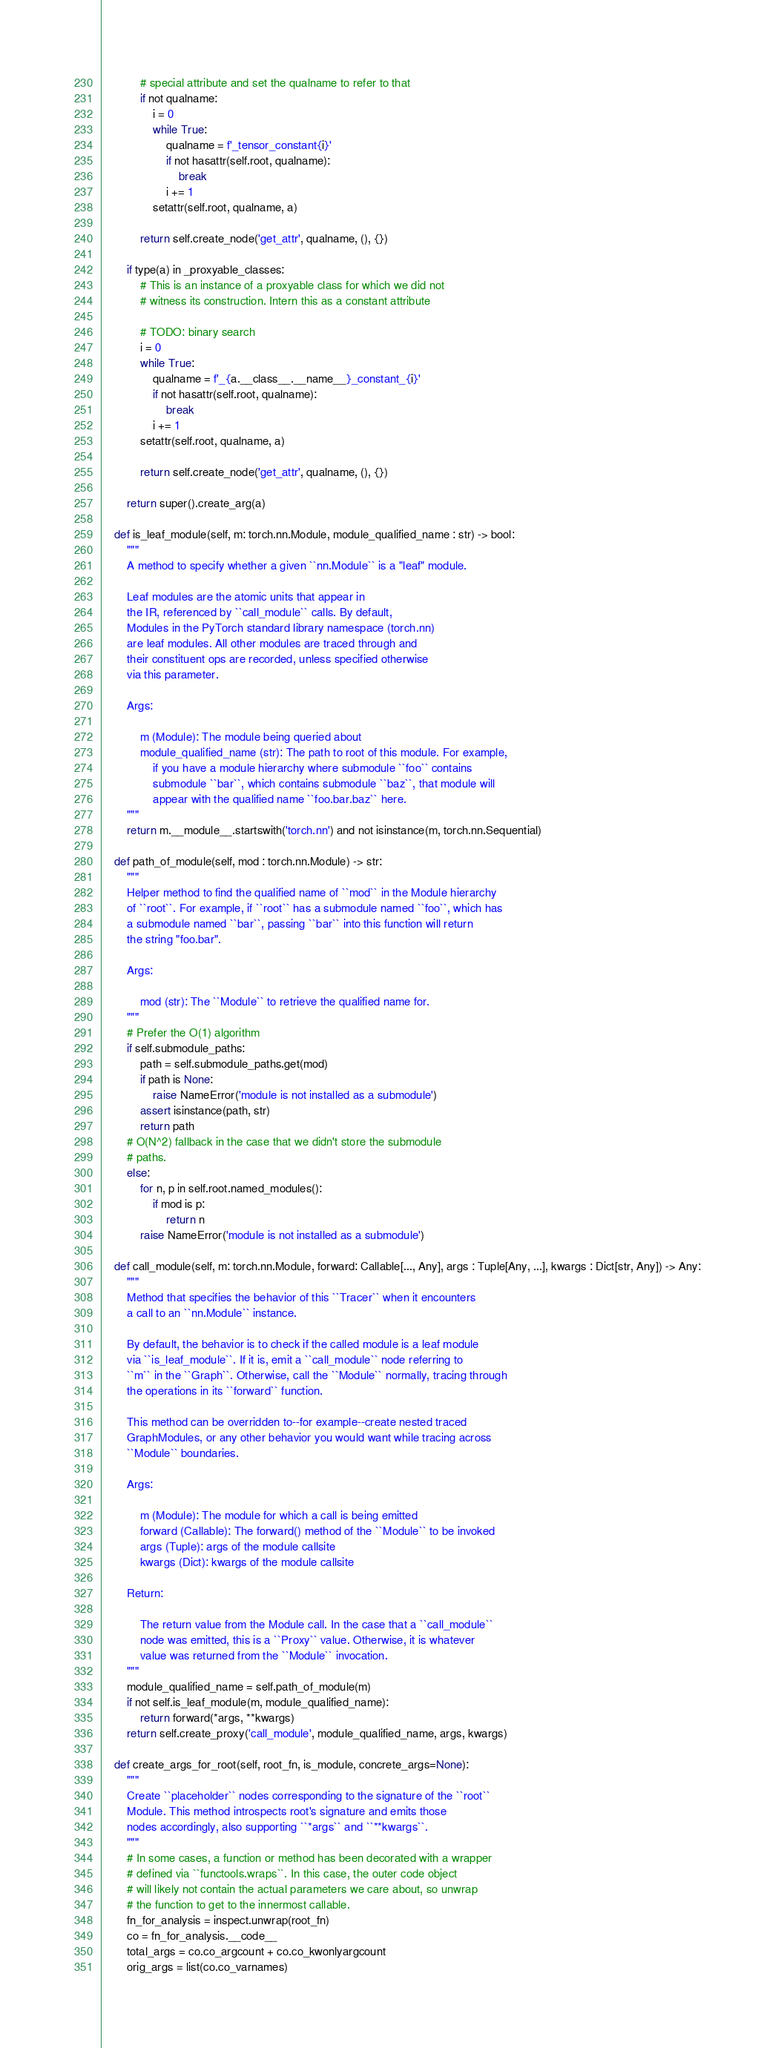Convert code to text. <code><loc_0><loc_0><loc_500><loc_500><_Python_>            # special attribute and set the qualname to refer to that
            if not qualname:
                i = 0
                while True:
                    qualname = f'_tensor_constant{i}'
                    if not hasattr(self.root, qualname):
                        break
                    i += 1
                setattr(self.root, qualname, a)

            return self.create_node('get_attr', qualname, (), {})

        if type(a) in _proxyable_classes:
            # This is an instance of a proxyable class for which we did not
            # witness its construction. Intern this as a constant attribute

            # TODO: binary search
            i = 0
            while True:
                qualname = f'_{a.__class__.__name__}_constant_{i}'
                if not hasattr(self.root, qualname):
                    break
                i += 1
            setattr(self.root, qualname, a)

            return self.create_node('get_attr', qualname, (), {})

        return super().create_arg(a)

    def is_leaf_module(self, m: torch.nn.Module, module_qualified_name : str) -> bool:
        """
        A method to specify whether a given ``nn.Module`` is a "leaf" module.

        Leaf modules are the atomic units that appear in
        the IR, referenced by ``call_module`` calls. By default,
        Modules in the PyTorch standard library namespace (torch.nn)
        are leaf modules. All other modules are traced through and
        their constituent ops are recorded, unless specified otherwise
        via this parameter.

        Args:

            m (Module): The module being queried about
            module_qualified_name (str): The path to root of this module. For example,
                if you have a module hierarchy where submodule ``foo`` contains
                submodule ``bar``, which contains submodule ``baz``, that module will
                appear with the qualified name ``foo.bar.baz`` here.
        """
        return m.__module__.startswith('torch.nn') and not isinstance(m, torch.nn.Sequential)

    def path_of_module(self, mod : torch.nn.Module) -> str:
        """
        Helper method to find the qualified name of ``mod`` in the Module hierarchy
        of ``root``. For example, if ``root`` has a submodule named ``foo``, which has
        a submodule named ``bar``, passing ``bar`` into this function will return
        the string "foo.bar".

        Args:

            mod (str): The ``Module`` to retrieve the qualified name for.
        """
        # Prefer the O(1) algorithm
        if self.submodule_paths:
            path = self.submodule_paths.get(mod)
            if path is None:
                raise NameError('module is not installed as a submodule')
            assert isinstance(path, str)
            return path
        # O(N^2) fallback in the case that we didn't store the submodule
        # paths.
        else:
            for n, p in self.root.named_modules():
                if mod is p:
                    return n
            raise NameError('module is not installed as a submodule')

    def call_module(self, m: torch.nn.Module, forward: Callable[..., Any], args : Tuple[Any, ...], kwargs : Dict[str, Any]) -> Any:
        """
        Method that specifies the behavior of this ``Tracer`` when it encounters
        a call to an ``nn.Module`` instance.

        By default, the behavior is to check if the called module is a leaf module
        via ``is_leaf_module``. If it is, emit a ``call_module`` node referring to
        ``m`` in the ``Graph``. Otherwise, call the ``Module`` normally, tracing through
        the operations in its ``forward`` function.

        This method can be overridden to--for example--create nested traced
        GraphModules, or any other behavior you would want while tracing across
        ``Module`` boundaries.

        Args:

            m (Module): The module for which a call is being emitted
            forward (Callable): The forward() method of the ``Module`` to be invoked
            args (Tuple): args of the module callsite
            kwargs (Dict): kwargs of the module callsite

        Return:

            The return value from the Module call. In the case that a ``call_module``
            node was emitted, this is a ``Proxy`` value. Otherwise, it is whatever
            value was returned from the ``Module`` invocation.
        """
        module_qualified_name = self.path_of_module(m)
        if not self.is_leaf_module(m, module_qualified_name):
            return forward(*args, **kwargs)
        return self.create_proxy('call_module', module_qualified_name, args, kwargs)

    def create_args_for_root(self, root_fn, is_module, concrete_args=None):
        """
        Create ``placeholder`` nodes corresponding to the signature of the ``root``
        Module. This method introspects root's signature and emits those
        nodes accordingly, also supporting ``*args`` and ``**kwargs``.
        """
        # In some cases, a function or method has been decorated with a wrapper
        # defined via ``functools.wraps``. In this case, the outer code object
        # will likely not contain the actual parameters we care about, so unwrap
        # the function to get to the innermost callable.
        fn_for_analysis = inspect.unwrap(root_fn)
        co = fn_for_analysis.__code__
        total_args = co.co_argcount + co.co_kwonlyargcount
        orig_args = list(co.co_varnames)</code> 